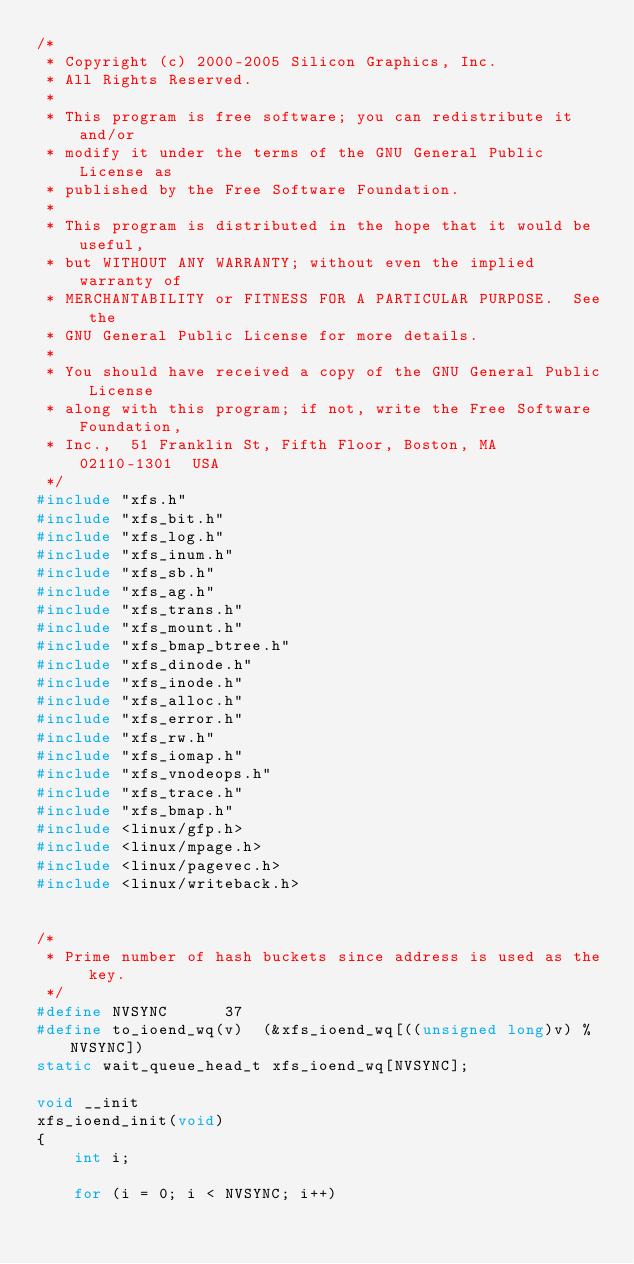Convert code to text. <code><loc_0><loc_0><loc_500><loc_500><_C_>/*
 * Copyright (c) 2000-2005 Silicon Graphics, Inc.
 * All Rights Reserved.
 *
 * This program is free software; you can redistribute it and/or
 * modify it under the terms of the GNU General Public License as
 * published by the Free Software Foundation.
 *
 * This program is distributed in the hope that it would be useful,
 * but WITHOUT ANY WARRANTY; without even the implied warranty of
 * MERCHANTABILITY or FITNESS FOR A PARTICULAR PURPOSE.  See the
 * GNU General Public License for more details.
 *
 * You should have received a copy of the GNU General Public License
 * along with this program; if not, write the Free Software Foundation,
 * Inc.,  51 Franklin St, Fifth Floor, Boston, MA  02110-1301  USA
 */
#include "xfs.h"
#include "xfs_bit.h"
#include "xfs_log.h"
#include "xfs_inum.h"
#include "xfs_sb.h"
#include "xfs_ag.h"
#include "xfs_trans.h"
#include "xfs_mount.h"
#include "xfs_bmap_btree.h"
#include "xfs_dinode.h"
#include "xfs_inode.h"
#include "xfs_alloc.h"
#include "xfs_error.h"
#include "xfs_rw.h"
#include "xfs_iomap.h"
#include "xfs_vnodeops.h"
#include "xfs_trace.h"
#include "xfs_bmap.h"
#include <linux/gfp.h>
#include <linux/mpage.h>
#include <linux/pagevec.h>
#include <linux/writeback.h>


/*
 * Prime number of hash buckets since address is used as the key.
 */
#define NVSYNC		37
#define to_ioend_wq(v)	(&xfs_ioend_wq[((unsigned long)v) % NVSYNC])
static wait_queue_head_t xfs_ioend_wq[NVSYNC];

void __init
xfs_ioend_init(void)
{
	int i;

	for (i = 0; i < NVSYNC; i++)</code> 